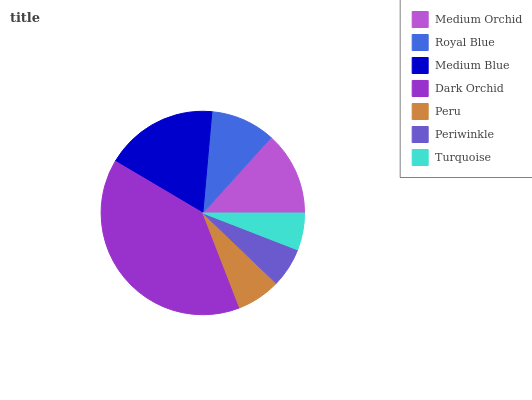Is Turquoise the minimum?
Answer yes or no. Yes. Is Dark Orchid the maximum?
Answer yes or no. Yes. Is Royal Blue the minimum?
Answer yes or no. No. Is Royal Blue the maximum?
Answer yes or no. No. Is Medium Orchid greater than Royal Blue?
Answer yes or no. Yes. Is Royal Blue less than Medium Orchid?
Answer yes or no. Yes. Is Royal Blue greater than Medium Orchid?
Answer yes or no. No. Is Medium Orchid less than Royal Blue?
Answer yes or no. No. Is Royal Blue the high median?
Answer yes or no. Yes. Is Royal Blue the low median?
Answer yes or no. Yes. Is Medium Blue the high median?
Answer yes or no. No. Is Peru the low median?
Answer yes or no. No. 